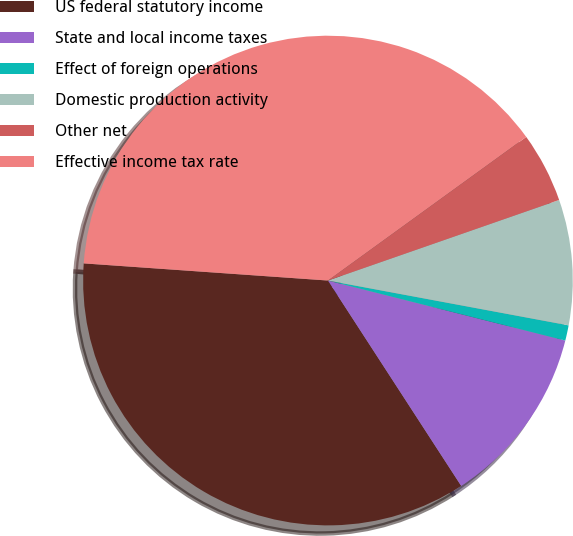<chart> <loc_0><loc_0><loc_500><loc_500><pie_chart><fcel>US federal statutory income<fcel>State and local income taxes<fcel>Effect of foreign operations<fcel>Domestic production activity<fcel>Other net<fcel>Effective income tax rate<nl><fcel>35.28%<fcel>11.9%<fcel>1.01%<fcel>8.27%<fcel>4.64%<fcel>38.91%<nl></chart> 